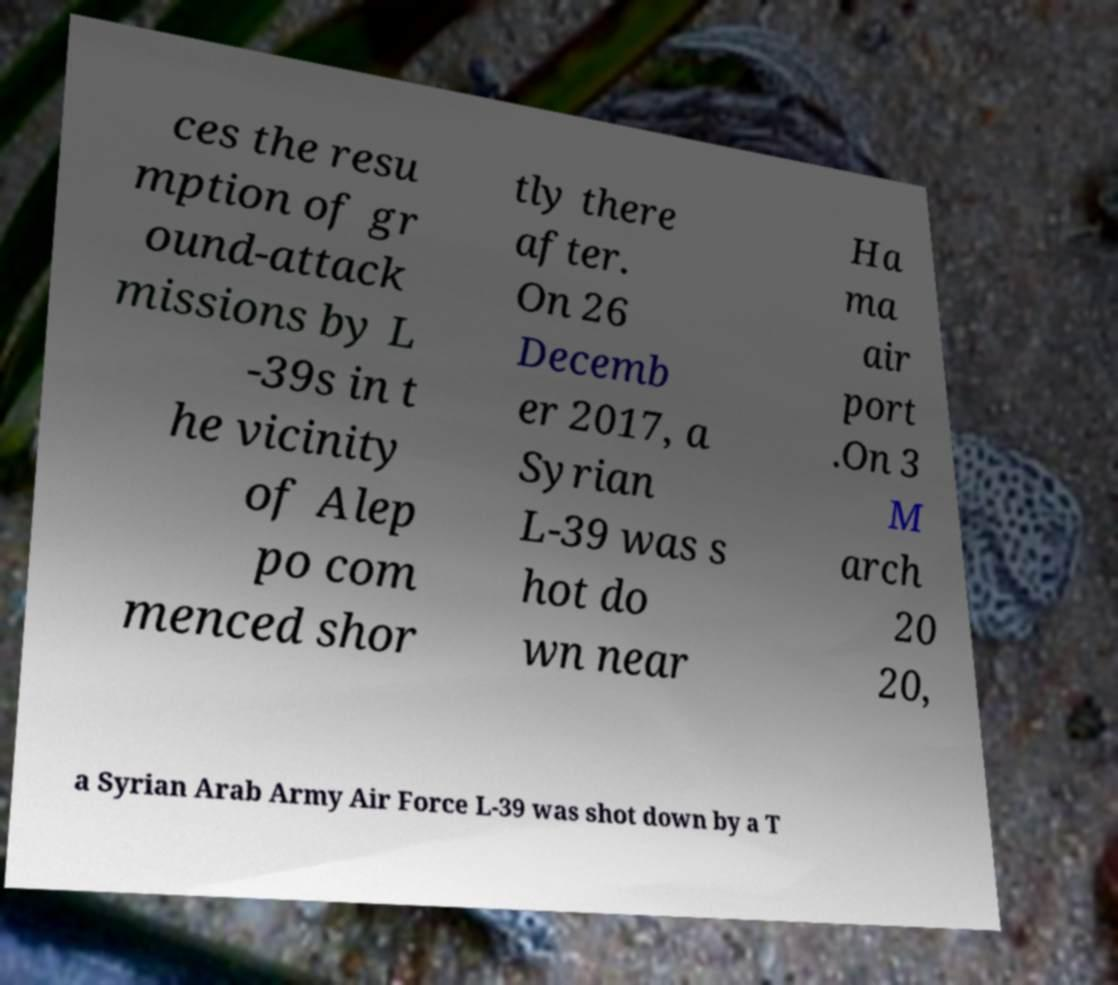Could you assist in decoding the text presented in this image and type it out clearly? ces the resu mption of gr ound-attack missions by L -39s in t he vicinity of Alep po com menced shor tly there after. On 26 Decemb er 2017, a Syrian L-39 was s hot do wn near Ha ma air port .On 3 M arch 20 20, a Syrian Arab Army Air Force L-39 was shot down by a T 